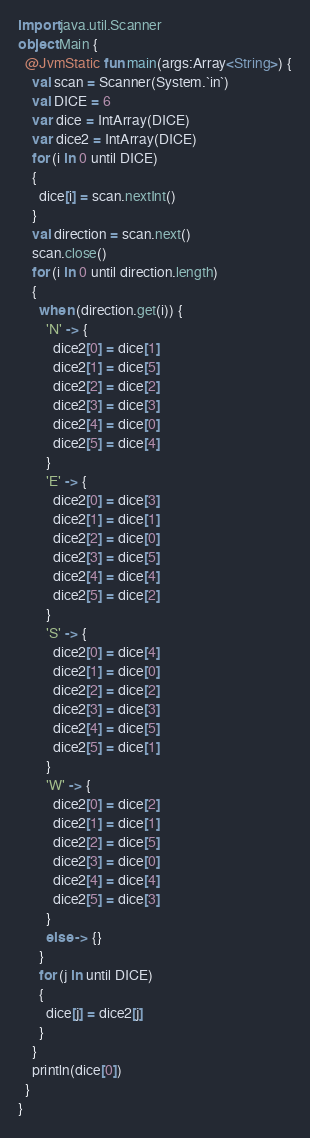<code> <loc_0><loc_0><loc_500><loc_500><_Kotlin_>import java.util.Scanner
object Main {
  @JvmStatic fun main(args:Array<String>) {
    val scan = Scanner(System.`in`)
    val DICE = 6
    var dice = IntArray(DICE)
    var dice2 = IntArray(DICE)
    for (i in 0 until DICE)
    {
      dice[i] = scan.nextInt()
    }
    val direction = scan.next()
    scan.close()
    for (i in 0 until direction.length)
    {
      when (direction.get(i)) {
        'N' -> {
          dice2[0] = dice[1]
          dice2[1] = dice[5]
          dice2[2] = dice[2]
          dice2[3] = dice[3]
          dice2[4] = dice[0]
          dice2[5] = dice[4]
        }
        'E' -> {
          dice2[0] = dice[3]
          dice2[1] = dice[1]
          dice2[2] = dice[0]
          dice2[3] = dice[5]
          dice2[4] = dice[4]
          dice2[5] = dice[2]
        }
        'S' -> {
          dice2[0] = dice[4]
          dice2[1] = dice[0]
          dice2[2] = dice[2]
          dice2[3] = dice[3]
          dice2[4] = dice[5]
          dice2[5] = dice[1]
        }
        'W' -> {
          dice2[0] = dice[2]
          dice2[1] = dice[1]
          dice2[2] = dice[5]
          dice2[3] = dice[0]
          dice2[4] = dice[4]
          dice2[5] = dice[3]
        }
        else -> {}
      }
      for (j in until DICE)
      {
        dice[j] = dice2[j]
      }
    }
    println(dice[0])
  }
}
</code> 